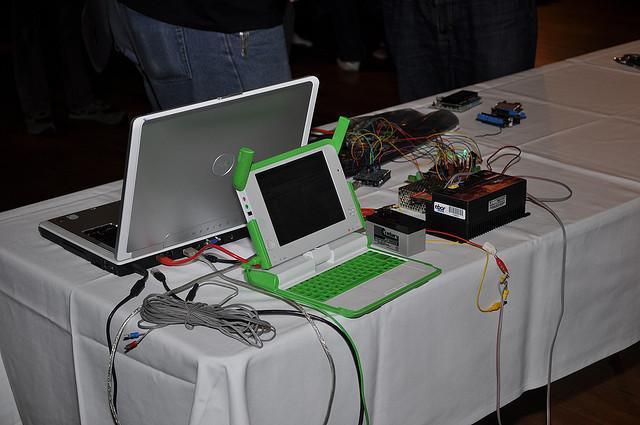How many laptops are in the picture?
Give a very brief answer. 2. How many people are there?
Give a very brief answer. 2. 